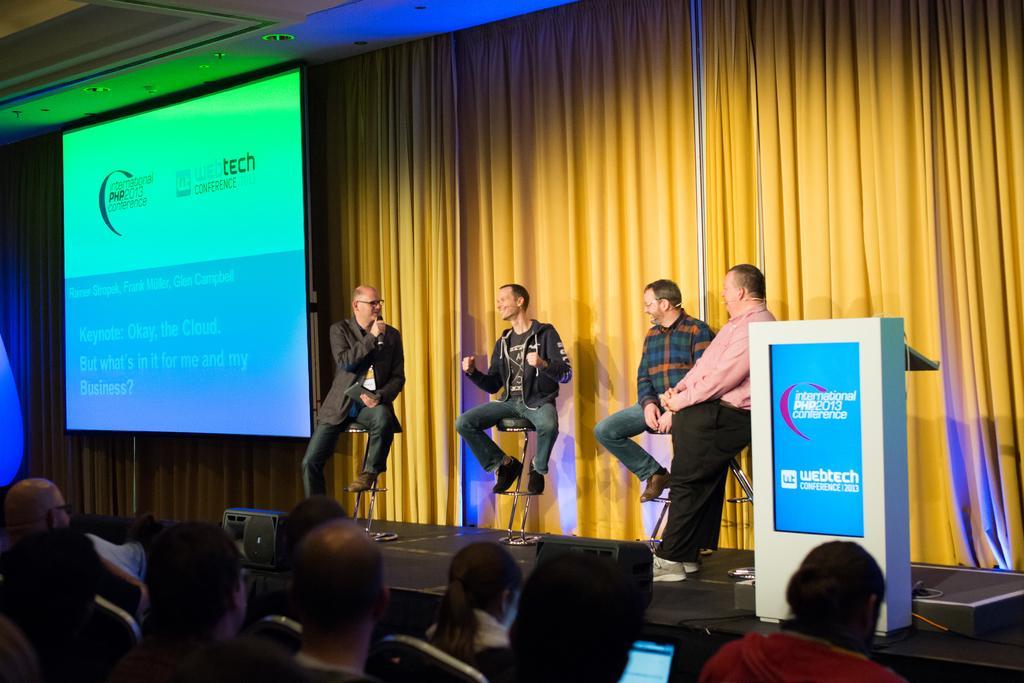Can you describe this image briefly? In this image I can see group of people. In front the person is wearing gray color blazer and holding a microphone, I can also see a podium, projection screen. Background I can see few cream color curtains. 